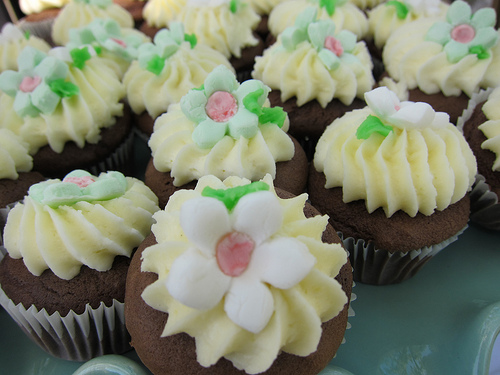<image>
Is there a flower on the cupcake? Yes. Looking at the image, I can see the flower is positioned on top of the cupcake, with the cupcake providing support. 